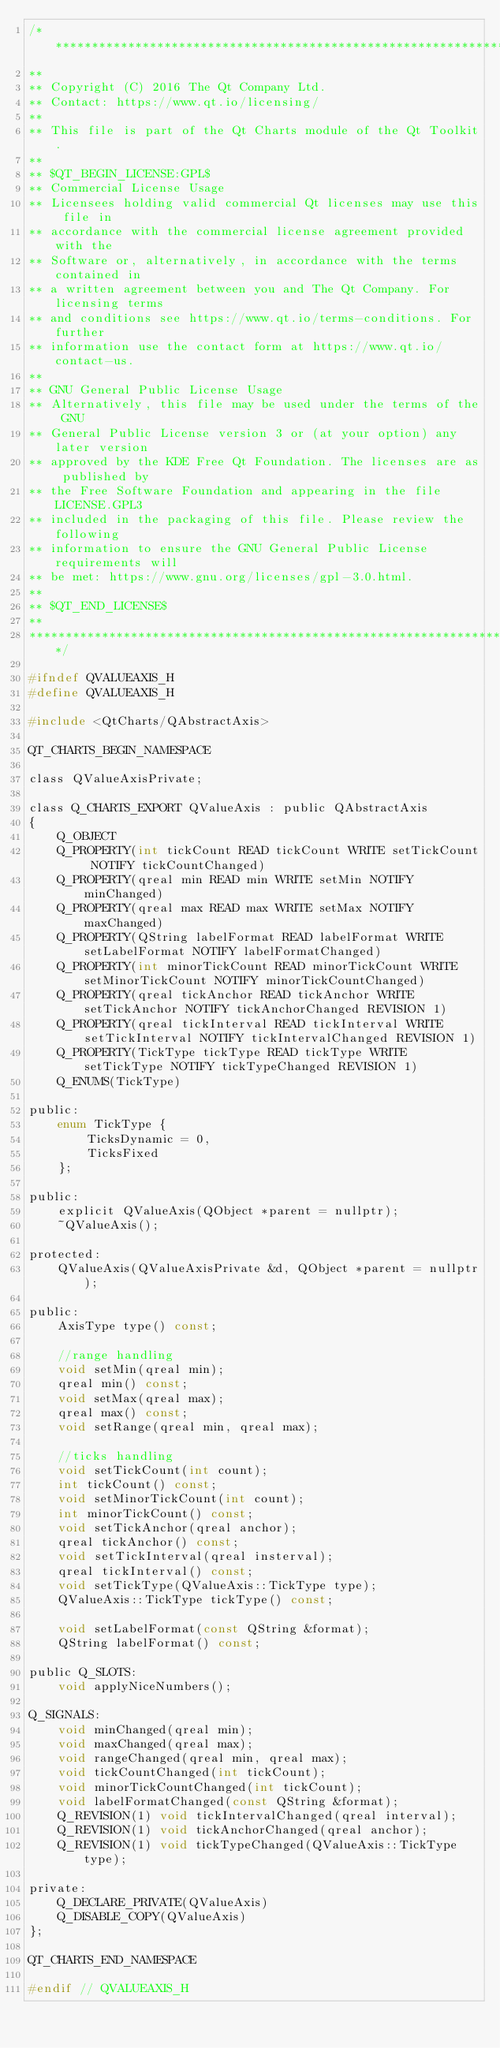<code> <loc_0><loc_0><loc_500><loc_500><_C_>/****************************************************************************
**
** Copyright (C) 2016 The Qt Company Ltd.
** Contact: https://www.qt.io/licensing/
**
** This file is part of the Qt Charts module of the Qt Toolkit.
**
** $QT_BEGIN_LICENSE:GPL$
** Commercial License Usage
** Licensees holding valid commercial Qt licenses may use this file in
** accordance with the commercial license agreement provided with the
** Software or, alternatively, in accordance with the terms contained in
** a written agreement between you and The Qt Company. For licensing terms
** and conditions see https://www.qt.io/terms-conditions. For further
** information use the contact form at https://www.qt.io/contact-us.
**
** GNU General Public License Usage
** Alternatively, this file may be used under the terms of the GNU
** General Public License version 3 or (at your option) any later version
** approved by the KDE Free Qt Foundation. The licenses are as published by
** the Free Software Foundation and appearing in the file LICENSE.GPL3
** included in the packaging of this file. Please review the following
** information to ensure the GNU General Public License requirements will
** be met: https://www.gnu.org/licenses/gpl-3.0.html.
**
** $QT_END_LICENSE$
**
****************************************************************************/

#ifndef QVALUEAXIS_H
#define QVALUEAXIS_H

#include <QtCharts/QAbstractAxis>

QT_CHARTS_BEGIN_NAMESPACE

class QValueAxisPrivate;

class Q_CHARTS_EXPORT QValueAxis : public QAbstractAxis
{
    Q_OBJECT
    Q_PROPERTY(int tickCount READ tickCount WRITE setTickCount NOTIFY tickCountChanged)
    Q_PROPERTY(qreal min READ min WRITE setMin NOTIFY minChanged)
    Q_PROPERTY(qreal max READ max WRITE setMax NOTIFY maxChanged)
    Q_PROPERTY(QString labelFormat READ labelFormat WRITE setLabelFormat NOTIFY labelFormatChanged)
    Q_PROPERTY(int minorTickCount READ minorTickCount WRITE setMinorTickCount NOTIFY minorTickCountChanged)
    Q_PROPERTY(qreal tickAnchor READ tickAnchor WRITE setTickAnchor NOTIFY tickAnchorChanged REVISION 1)
    Q_PROPERTY(qreal tickInterval READ tickInterval WRITE setTickInterval NOTIFY tickIntervalChanged REVISION 1)
    Q_PROPERTY(TickType tickType READ tickType WRITE setTickType NOTIFY tickTypeChanged REVISION 1)
    Q_ENUMS(TickType)

public:
    enum TickType {
        TicksDynamic = 0,
        TicksFixed
    };

public:
    explicit QValueAxis(QObject *parent = nullptr);
    ~QValueAxis();

protected:
    QValueAxis(QValueAxisPrivate &d, QObject *parent = nullptr);

public:
    AxisType type() const;

    //range handling
    void setMin(qreal min);
    qreal min() const;
    void setMax(qreal max);
    qreal max() const;
    void setRange(qreal min, qreal max);

    //ticks handling
    void setTickCount(int count);
    int tickCount() const;
    void setMinorTickCount(int count);
    int minorTickCount() const;
    void setTickAnchor(qreal anchor);
    qreal tickAnchor() const;
    void setTickInterval(qreal insterval);
    qreal tickInterval() const;
    void setTickType(QValueAxis::TickType type);
    QValueAxis::TickType tickType() const;

    void setLabelFormat(const QString &format);
    QString labelFormat() const;

public Q_SLOTS:
    void applyNiceNumbers();

Q_SIGNALS:
    void minChanged(qreal min);
    void maxChanged(qreal max);
    void rangeChanged(qreal min, qreal max);
    void tickCountChanged(int tickCount);
    void minorTickCountChanged(int tickCount);
    void labelFormatChanged(const QString &format);
    Q_REVISION(1) void tickIntervalChanged(qreal interval);
    Q_REVISION(1) void tickAnchorChanged(qreal anchor);
    Q_REVISION(1) void tickTypeChanged(QValueAxis::TickType type);

private:
    Q_DECLARE_PRIVATE(QValueAxis)
    Q_DISABLE_COPY(QValueAxis)
};

QT_CHARTS_END_NAMESPACE

#endif // QVALUEAXIS_H
</code> 